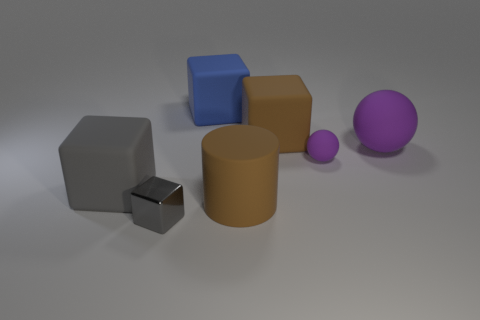Which objects in this image could likely be the heaviest? If we consider the physical properties usually associated with the objects' sizes and materials, the largest matte block to the left and the large blue cube might be the heaviest objects in the image, assuming they are made from materials of similar density. 